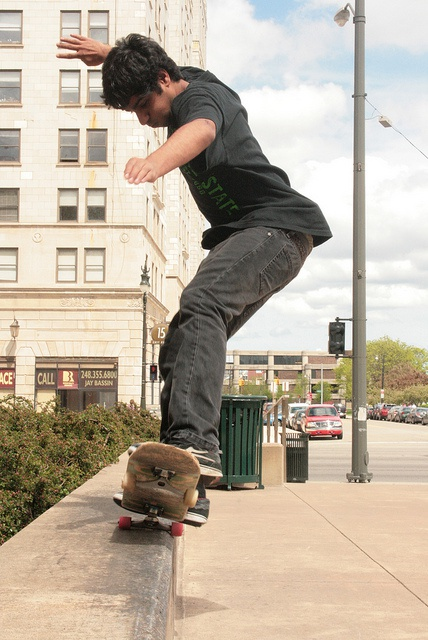Describe the objects in this image and their specific colors. I can see people in ivory, gray, black, white, and tan tones, skateboard in ivory, maroon, black, and gray tones, car in ivory, lightgray, darkgray, lightpink, and salmon tones, traffic light in ivory, gray, and black tones, and car in ivory, white, darkgray, gray, and tan tones in this image. 